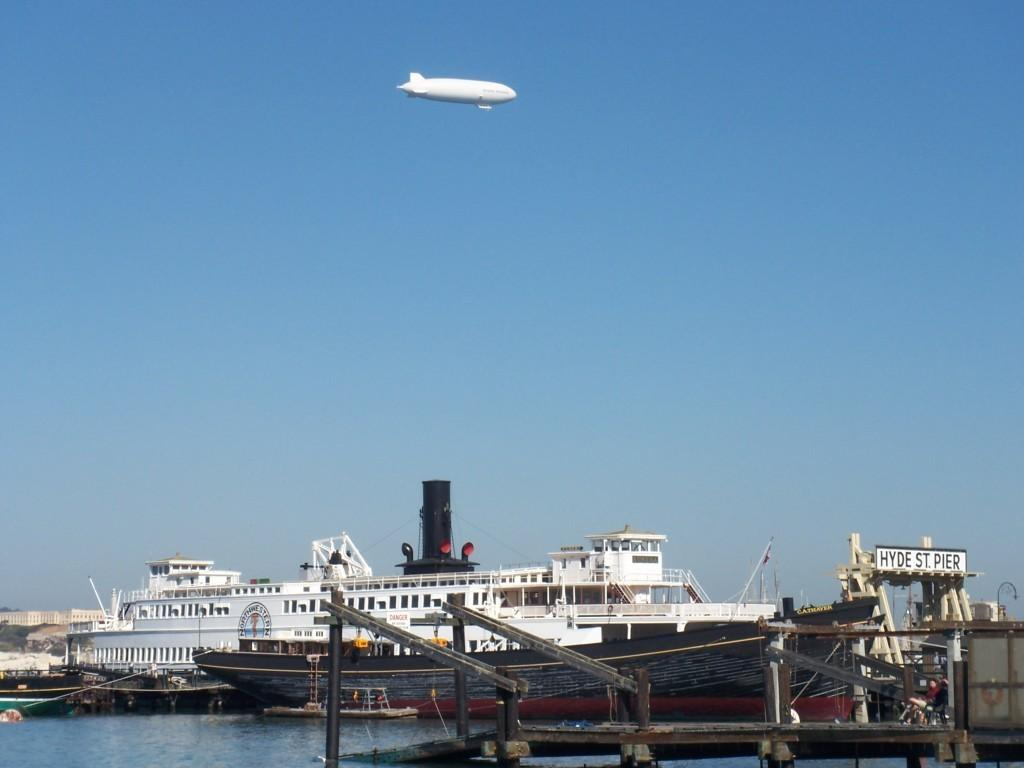What is located in the water in the image? There is a ship in the water. What other mode of transportation can be seen in the image? There are boats in the water. What is the color of the sky in the image? The sky is blue. What type of structures are visible in the image? There are buildings visible in the image. What is the second mode of transportation in the image? There is an air balloon in the image. Who is the creator of the monkey in the image? There is no monkey present in the image. What type of work is the monkey doing in the image? There is no monkey present in the image, so it cannot be determined what type of work it might be doing. 